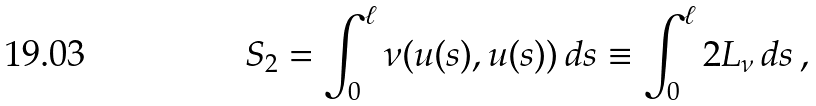Convert formula to latex. <formula><loc_0><loc_0><loc_500><loc_500>S _ { 2 } = \int _ { 0 } ^ { \ell } { \nu ( u ( s ) , u ( s ) ) } \, d s \equiv \int _ { 0 } ^ { \ell } 2 L _ { \nu } \, d s \, ,</formula> 